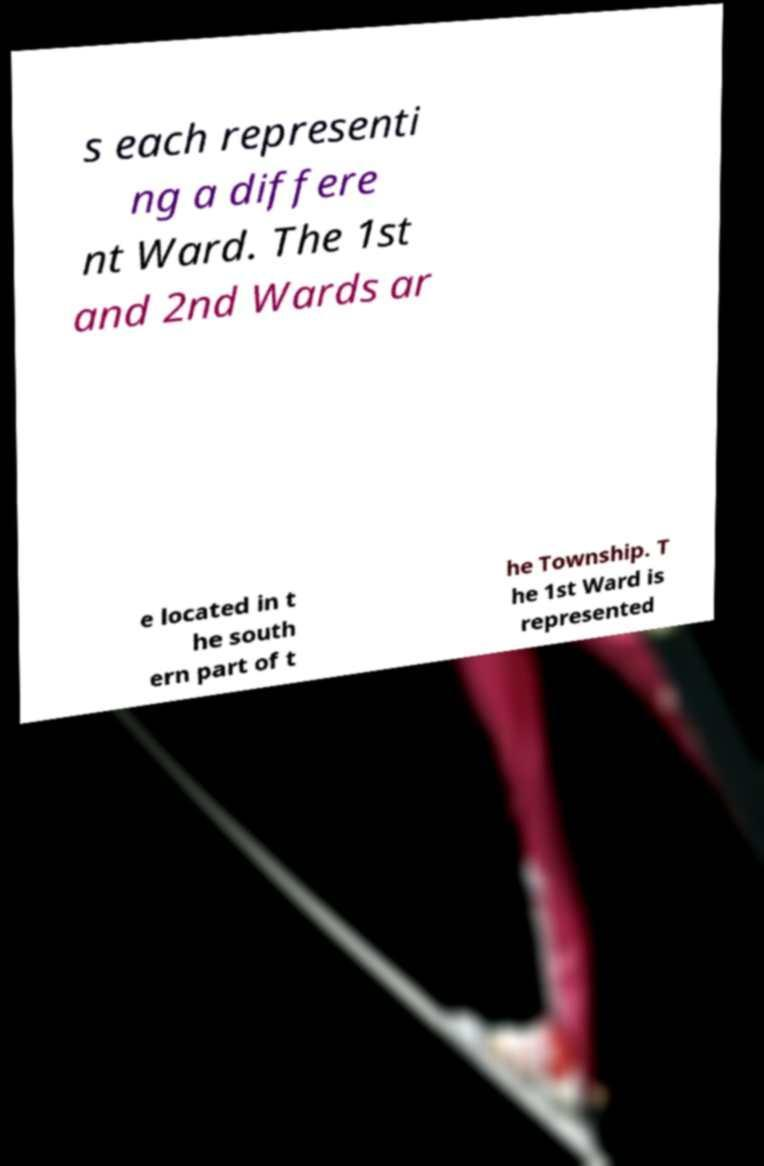There's text embedded in this image that I need extracted. Can you transcribe it verbatim? s each representi ng a differe nt Ward. The 1st and 2nd Wards ar e located in t he south ern part of t he Township. T he 1st Ward is represented 